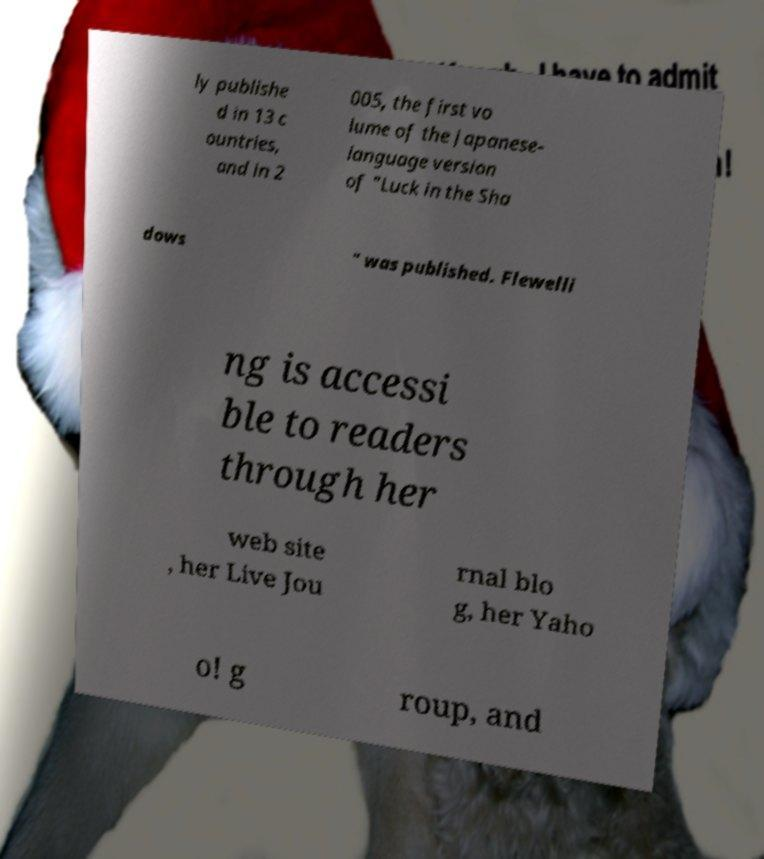Please read and relay the text visible in this image. What does it say? ly publishe d in 13 c ountries, and in 2 005, the first vo lume of the Japanese- language version of "Luck in the Sha dows " was published. Flewelli ng is accessi ble to readers through her web site , her Live Jou rnal blo g, her Yaho o! g roup, and 